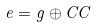Convert formula to latex. <formula><loc_0><loc_0><loc_500><loc_500>e = g \oplus C C</formula> 